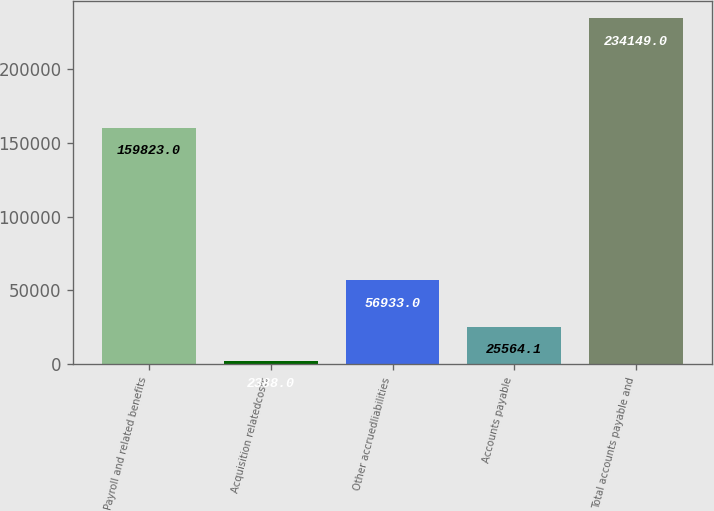Convert chart to OTSL. <chart><loc_0><loc_0><loc_500><loc_500><bar_chart><fcel>Payroll and related benefits<fcel>Acquisition relatedcosts<fcel>Other accruedliabilities<fcel>Accounts payable<fcel>Total accounts payable and<nl><fcel>159823<fcel>2388<fcel>56933<fcel>25564.1<fcel>234149<nl></chart> 